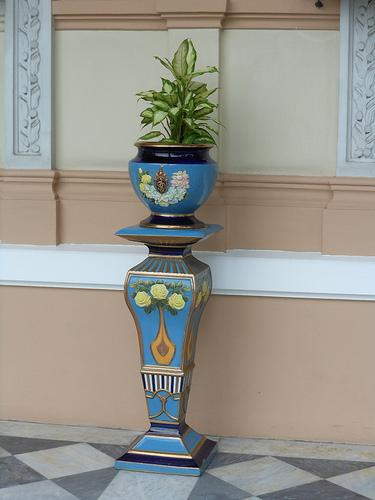Question: what color is the plant?
Choices:
A. Yellow.
B. Green.
C. Brown.
D. Purple.
Answer with the letter. Answer: B Question: who made the stand?
Choices:
A. A man.
B. A woman.
C. A woodworker.
D. John.
Answer with the letter. Answer: C Question: what color are the painted flowers?
Choices:
A. Red.
B. Pink.
C. Yellow.
D. Purple.
Answer with the letter. Answer: C Question: how many vases are there?
Choices:
A. Two.
B. One.
C. Three.
D. Four.
Answer with the letter. Answer: B 